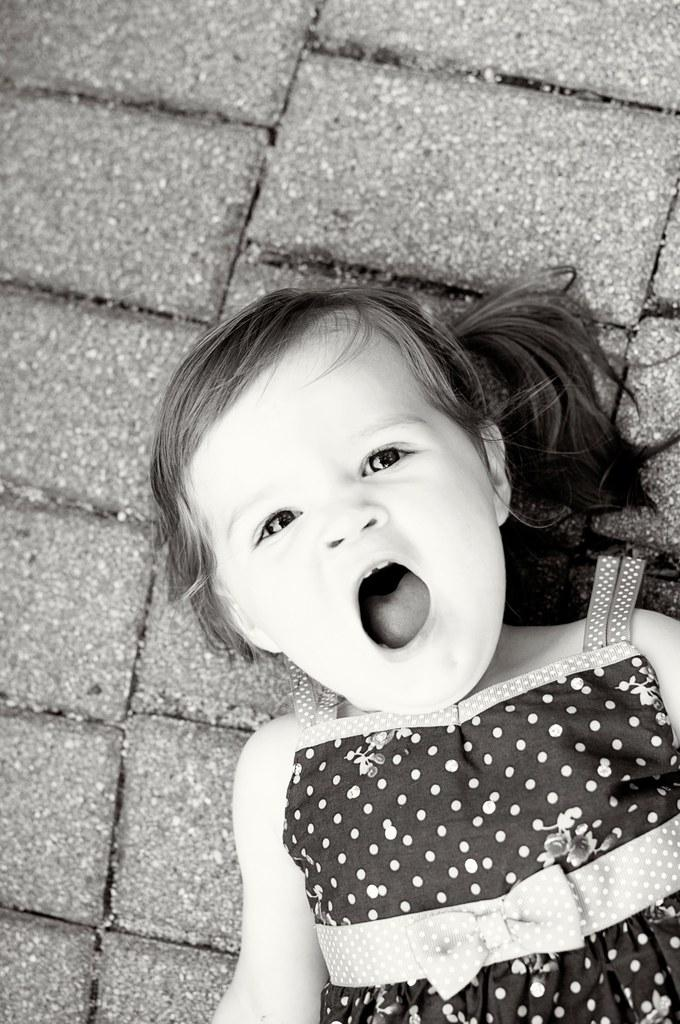Who is the main subject in the image? There is a girl in the image. What is the girl doing in the image? The girl is laying on a surface and looking at something. What is the girl's facial expression in the image? The girl has her mouth open in the image. What type of canvas is the girl painting on in the image? There is no canvas present in the image, and the girl is not shown painting. 